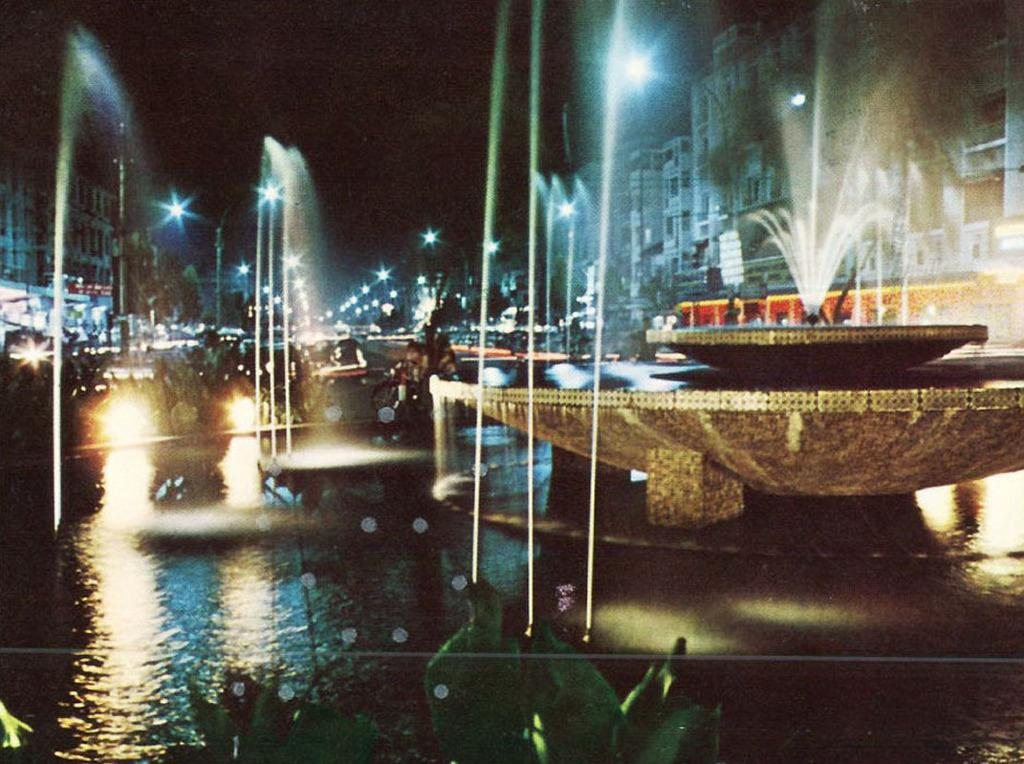What type of structures are present in the image? There are buildings in the image. What features can be seen on the buildings? The buildings have windows. What else is present in the image besides the buildings? There are poles and lights in the image. Is there any other notable feature in the image? Yes, there is a water fountain in the image. What activity is the fireman performing in the image? There is no fireman present in the image, so no activity involving a fireman can be observed. 